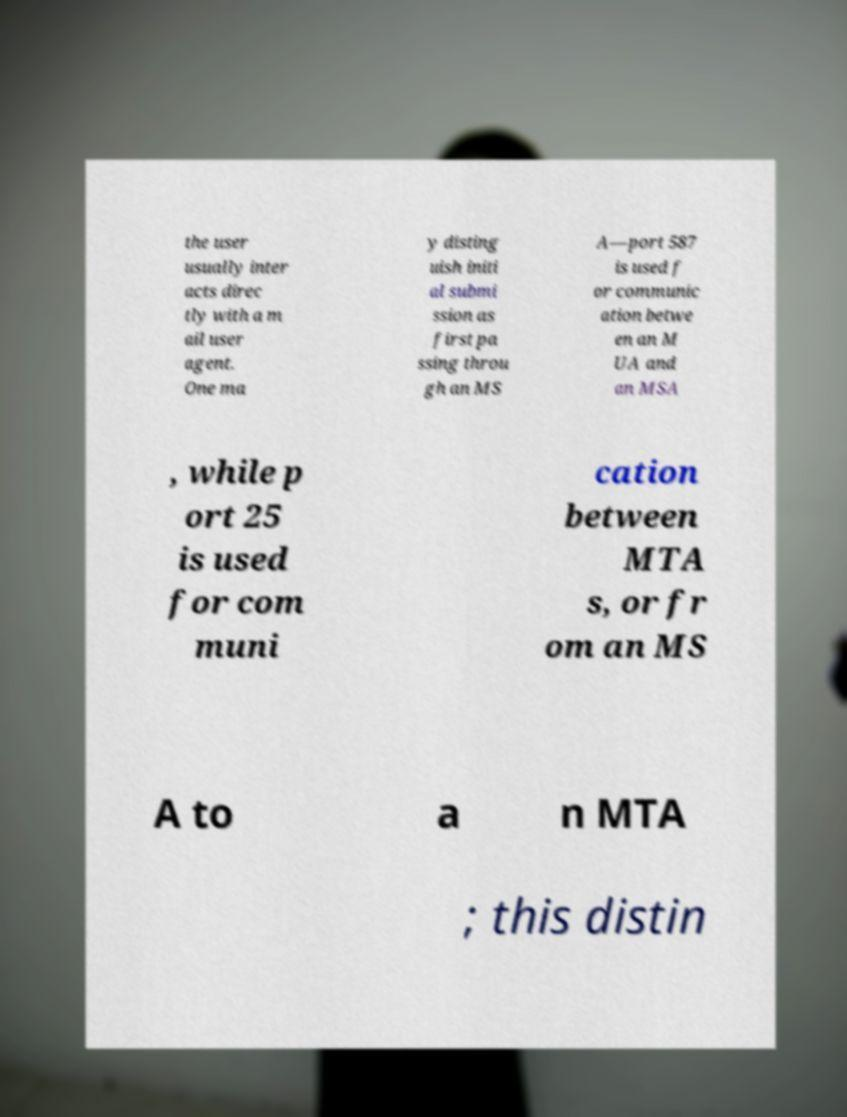Could you assist in decoding the text presented in this image and type it out clearly? the user usually inter acts direc tly with a m ail user agent. One ma y disting uish initi al submi ssion as first pa ssing throu gh an MS A—port 587 is used f or communic ation betwe en an M UA and an MSA , while p ort 25 is used for com muni cation between MTA s, or fr om an MS A to a n MTA ; this distin 